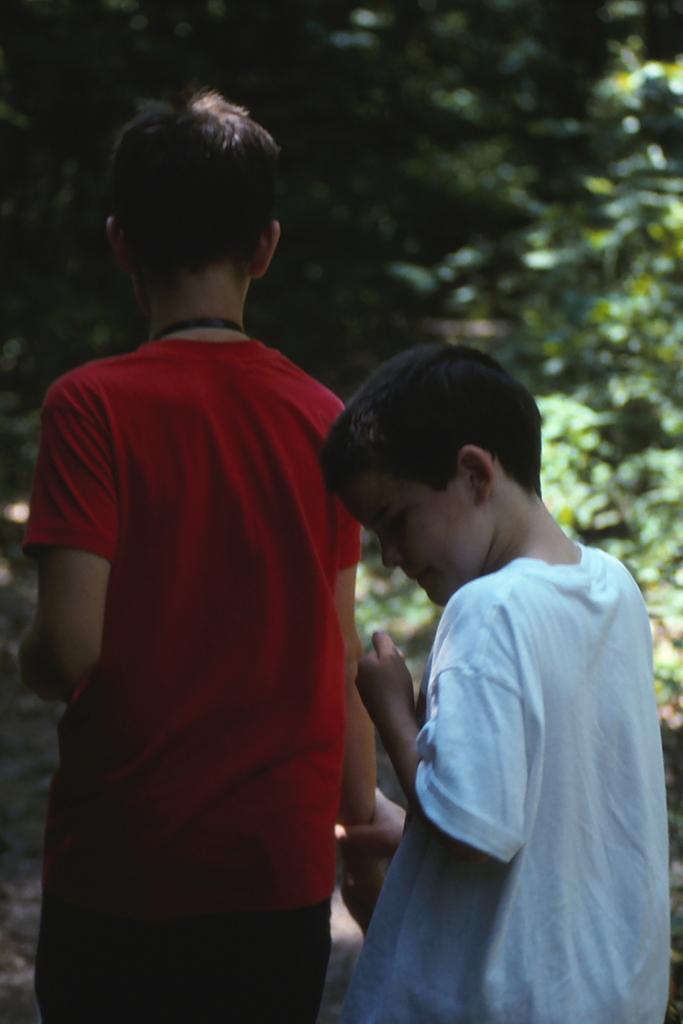Can you describe this image briefly? In this image I see 2 boys in which this boy is wearing red color t-shirt and this boy is wearing white color t-shirt and in the background I see the green leaves and I see that it is blurred. 